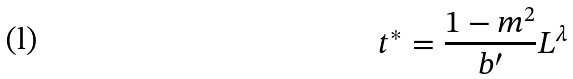<formula> <loc_0><loc_0><loc_500><loc_500>t ^ { * } = \frac { 1 - m ^ { 2 } } { b ^ { \prime } } L ^ { \lambda }</formula> 